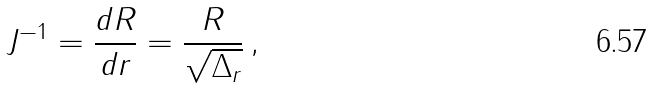<formula> <loc_0><loc_0><loc_500><loc_500>J ^ { - 1 } = \frac { d R } { d r } = \frac { R } { \sqrt { \Delta _ { r } } } \, ,</formula> 